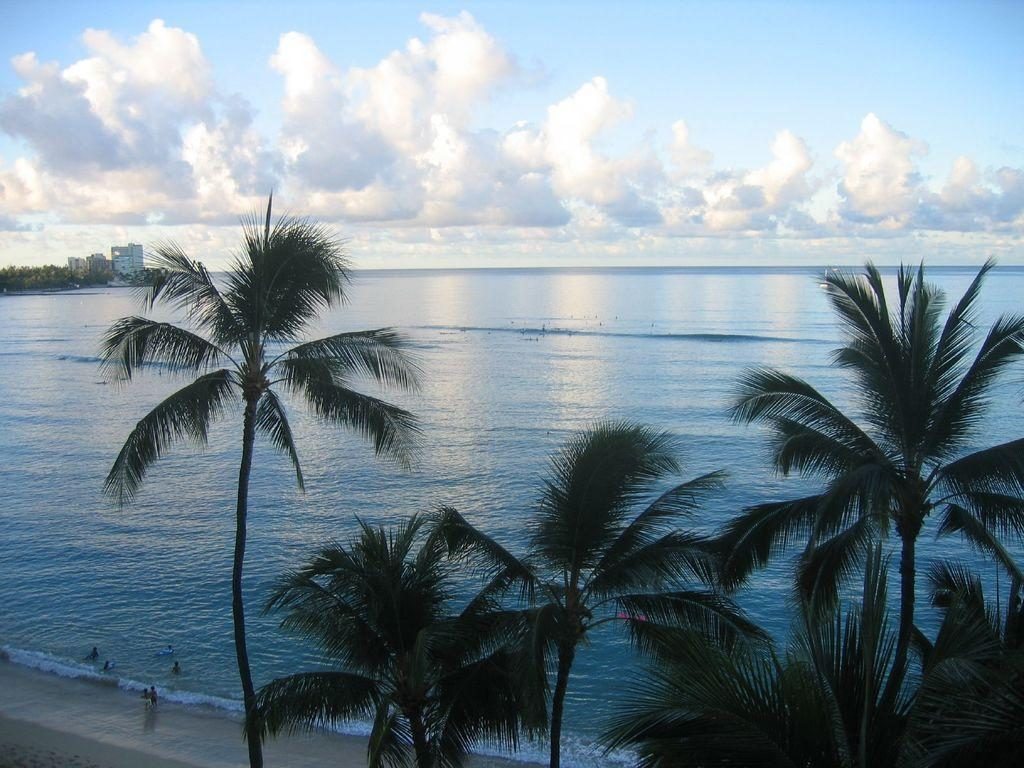What type of natural environment is visible in the image? The image features a beach. What can be seen beside the beach in the image? There are trees beside the beach in the image. What is visible in the sky in the image? There are clouds visible in the sky in the image. What flavor of bag can be seen in the image? There is no bag present in the image, so it is not possible to determine the flavor of any bag. 